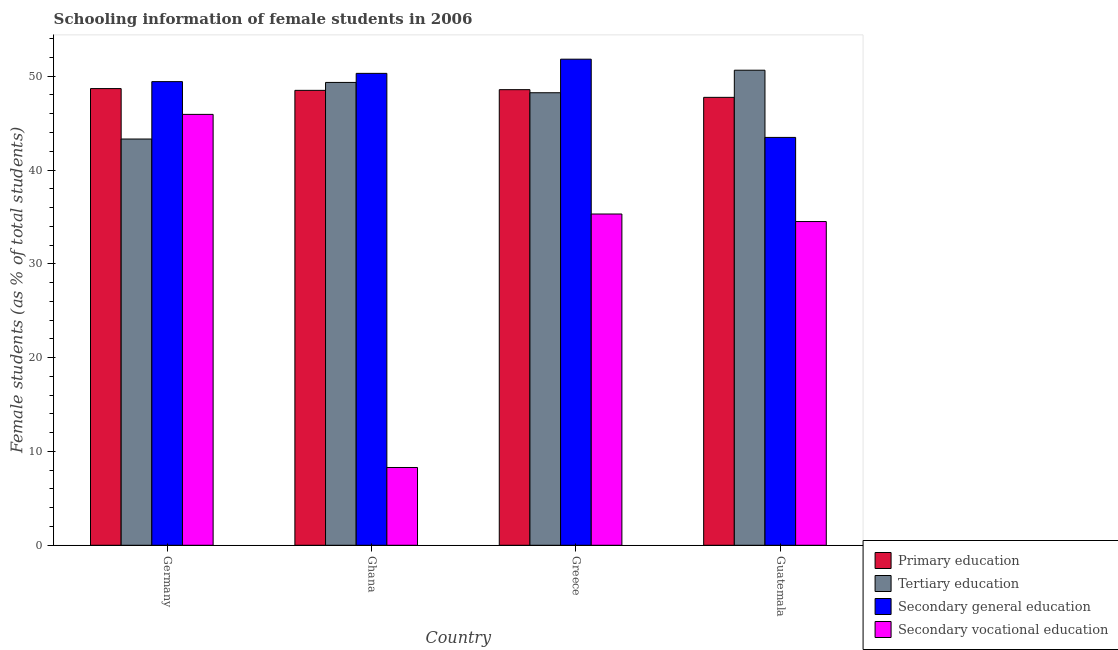How many groups of bars are there?
Your answer should be compact. 4. In how many cases, is the number of bars for a given country not equal to the number of legend labels?
Your response must be concise. 0. What is the percentage of female students in tertiary education in Guatemala?
Your answer should be very brief. 50.64. Across all countries, what is the maximum percentage of female students in secondary education?
Your response must be concise. 51.81. Across all countries, what is the minimum percentage of female students in tertiary education?
Make the answer very short. 43.3. In which country was the percentage of female students in tertiary education minimum?
Offer a terse response. Germany. What is the total percentage of female students in secondary education in the graph?
Your answer should be compact. 195.01. What is the difference between the percentage of female students in tertiary education in Ghana and that in Greece?
Provide a succinct answer. 1.1. What is the difference between the percentage of female students in secondary education in Greece and the percentage of female students in tertiary education in Guatemala?
Ensure brevity in your answer.  1.18. What is the average percentage of female students in primary education per country?
Provide a short and direct response. 48.37. What is the difference between the percentage of female students in tertiary education and percentage of female students in primary education in Ghana?
Your answer should be compact. 0.85. What is the ratio of the percentage of female students in secondary education in Germany to that in Greece?
Provide a short and direct response. 0.95. Is the percentage of female students in tertiary education in Ghana less than that in Greece?
Your response must be concise. No. Is the difference between the percentage of female students in secondary vocational education in Ghana and Guatemala greater than the difference between the percentage of female students in tertiary education in Ghana and Guatemala?
Provide a short and direct response. No. What is the difference between the highest and the second highest percentage of female students in secondary education?
Your answer should be compact. 1.51. What is the difference between the highest and the lowest percentage of female students in primary education?
Offer a terse response. 0.93. Is it the case that in every country, the sum of the percentage of female students in primary education and percentage of female students in secondary education is greater than the sum of percentage of female students in tertiary education and percentage of female students in secondary vocational education?
Your answer should be very brief. No. What does the 1st bar from the left in Guatemala represents?
Your response must be concise. Primary education. What does the 1st bar from the right in Greece represents?
Give a very brief answer. Secondary vocational education. How many bars are there?
Offer a terse response. 16. How many countries are there in the graph?
Make the answer very short. 4. Does the graph contain any zero values?
Keep it short and to the point. No. Where does the legend appear in the graph?
Give a very brief answer. Bottom right. How many legend labels are there?
Ensure brevity in your answer.  4. How are the legend labels stacked?
Make the answer very short. Vertical. What is the title of the graph?
Provide a short and direct response. Schooling information of female students in 2006. What is the label or title of the X-axis?
Provide a short and direct response. Country. What is the label or title of the Y-axis?
Provide a succinct answer. Female students (as % of total students). What is the Female students (as % of total students) of Primary education in Germany?
Give a very brief answer. 48.68. What is the Female students (as % of total students) in Tertiary education in Germany?
Ensure brevity in your answer.  43.3. What is the Female students (as % of total students) in Secondary general education in Germany?
Your answer should be very brief. 49.42. What is the Female students (as % of total students) of Secondary vocational education in Germany?
Offer a very short reply. 45.93. What is the Female students (as % of total students) in Primary education in Ghana?
Offer a very short reply. 48.49. What is the Female students (as % of total students) in Tertiary education in Ghana?
Keep it short and to the point. 49.34. What is the Female students (as % of total students) of Secondary general education in Ghana?
Offer a terse response. 50.3. What is the Female students (as % of total students) in Secondary vocational education in Ghana?
Keep it short and to the point. 8.29. What is the Female students (as % of total students) in Primary education in Greece?
Ensure brevity in your answer.  48.57. What is the Female students (as % of total students) of Tertiary education in Greece?
Your response must be concise. 48.24. What is the Female students (as % of total students) of Secondary general education in Greece?
Give a very brief answer. 51.81. What is the Female students (as % of total students) in Secondary vocational education in Greece?
Give a very brief answer. 35.31. What is the Female students (as % of total students) of Primary education in Guatemala?
Make the answer very short. 47.75. What is the Female students (as % of total students) of Tertiary education in Guatemala?
Keep it short and to the point. 50.64. What is the Female students (as % of total students) in Secondary general education in Guatemala?
Ensure brevity in your answer.  43.48. What is the Female students (as % of total students) in Secondary vocational education in Guatemala?
Provide a succinct answer. 34.51. Across all countries, what is the maximum Female students (as % of total students) of Primary education?
Provide a short and direct response. 48.68. Across all countries, what is the maximum Female students (as % of total students) in Tertiary education?
Make the answer very short. 50.64. Across all countries, what is the maximum Female students (as % of total students) of Secondary general education?
Keep it short and to the point. 51.81. Across all countries, what is the maximum Female students (as % of total students) in Secondary vocational education?
Your response must be concise. 45.93. Across all countries, what is the minimum Female students (as % of total students) of Primary education?
Provide a short and direct response. 47.75. Across all countries, what is the minimum Female students (as % of total students) of Tertiary education?
Provide a short and direct response. 43.3. Across all countries, what is the minimum Female students (as % of total students) of Secondary general education?
Your answer should be very brief. 43.48. Across all countries, what is the minimum Female students (as % of total students) of Secondary vocational education?
Ensure brevity in your answer.  8.29. What is the total Female students (as % of total students) of Primary education in the graph?
Provide a succinct answer. 193.48. What is the total Female students (as % of total students) of Tertiary education in the graph?
Your response must be concise. 191.52. What is the total Female students (as % of total students) in Secondary general education in the graph?
Keep it short and to the point. 195.01. What is the total Female students (as % of total students) of Secondary vocational education in the graph?
Give a very brief answer. 124.04. What is the difference between the Female students (as % of total students) of Primary education in Germany and that in Ghana?
Ensure brevity in your answer.  0.19. What is the difference between the Female students (as % of total students) of Tertiary education in Germany and that in Ghana?
Provide a short and direct response. -6.03. What is the difference between the Female students (as % of total students) in Secondary general education in Germany and that in Ghana?
Your answer should be very brief. -0.88. What is the difference between the Female students (as % of total students) of Secondary vocational education in Germany and that in Ghana?
Your response must be concise. 37.64. What is the difference between the Female students (as % of total students) in Primary education in Germany and that in Greece?
Your answer should be very brief. 0.11. What is the difference between the Female students (as % of total students) of Tertiary education in Germany and that in Greece?
Ensure brevity in your answer.  -4.93. What is the difference between the Female students (as % of total students) in Secondary general education in Germany and that in Greece?
Your response must be concise. -2.39. What is the difference between the Female students (as % of total students) of Secondary vocational education in Germany and that in Greece?
Offer a terse response. 10.62. What is the difference between the Female students (as % of total students) of Primary education in Germany and that in Guatemala?
Provide a succinct answer. 0.93. What is the difference between the Female students (as % of total students) of Tertiary education in Germany and that in Guatemala?
Your answer should be very brief. -7.33. What is the difference between the Female students (as % of total students) in Secondary general education in Germany and that in Guatemala?
Keep it short and to the point. 5.95. What is the difference between the Female students (as % of total students) of Secondary vocational education in Germany and that in Guatemala?
Give a very brief answer. 11.42. What is the difference between the Female students (as % of total students) of Primary education in Ghana and that in Greece?
Make the answer very short. -0.07. What is the difference between the Female students (as % of total students) of Tertiary education in Ghana and that in Greece?
Ensure brevity in your answer.  1.1. What is the difference between the Female students (as % of total students) in Secondary general education in Ghana and that in Greece?
Provide a short and direct response. -1.51. What is the difference between the Female students (as % of total students) of Secondary vocational education in Ghana and that in Greece?
Give a very brief answer. -27.02. What is the difference between the Female students (as % of total students) in Primary education in Ghana and that in Guatemala?
Your answer should be compact. 0.75. What is the difference between the Female students (as % of total students) in Tertiary education in Ghana and that in Guatemala?
Your response must be concise. -1.3. What is the difference between the Female students (as % of total students) of Secondary general education in Ghana and that in Guatemala?
Provide a short and direct response. 6.83. What is the difference between the Female students (as % of total students) in Secondary vocational education in Ghana and that in Guatemala?
Keep it short and to the point. -26.22. What is the difference between the Female students (as % of total students) of Primary education in Greece and that in Guatemala?
Make the answer very short. 0.82. What is the difference between the Female students (as % of total students) in Tertiary education in Greece and that in Guatemala?
Your answer should be compact. -2.4. What is the difference between the Female students (as % of total students) in Secondary general education in Greece and that in Guatemala?
Ensure brevity in your answer.  8.34. What is the difference between the Female students (as % of total students) of Secondary vocational education in Greece and that in Guatemala?
Your answer should be compact. 0.8. What is the difference between the Female students (as % of total students) in Primary education in Germany and the Female students (as % of total students) in Tertiary education in Ghana?
Keep it short and to the point. -0.66. What is the difference between the Female students (as % of total students) of Primary education in Germany and the Female students (as % of total students) of Secondary general education in Ghana?
Provide a succinct answer. -1.62. What is the difference between the Female students (as % of total students) of Primary education in Germany and the Female students (as % of total students) of Secondary vocational education in Ghana?
Your answer should be very brief. 40.39. What is the difference between the Female students (as % of total students) in Tertiary education in Germany and the Female students (as % of total students) in Secondary general education in Ghana?
Your answer should be compact. -7. What is the difference between the Female students (as % of total students) of Tertiary education in Germany and the Female students (as % of total students) of Secondary vocational education in Ghana?
Offer a terse response. 35.01. What is the difference between the Female students (as % of total students) of Secondary general education in Germany and the Female students (as % of total students) of Secondary vocational education in Ghana?
Make the answer very short. 41.13. What is the difference between the Female students (as % of total students) in Primary education in Germany and the Female students (as % of total students) in Tertiary education in Greece?
Make the answer very short. 0.44. What is the difference between the Female students (as % of total students) in Primary education in Germany and the Female students (as % of total students) in Secondary general education in Greece?
Your answer should be compact. -3.13. What is the difference between the Female students (as % of total students) in Primary education in Germany and the Female students (as % of total students) in Secondary vocational education in Greece?
Offer a terse response. 13.37. What is the difference between the Female students (as % of total students) of Tertiary education in Germany and the Female students (as % of total students) of Secondary general education in Greece?
Ensure brevity in your answer.  -8.51. What is the difference between the Female students (as % of total students) of Tertiary education in Germany and the Female students (as % of total students) of Secondary vocational education in Greece?
Offer a very short reply. 7.99. What is the difference between the Female students (as % of total students) in Secondary general education in Germany and the Female students (as % of total students) in Secondary vocational education in Greece?
Offer a terse response. 14.11. What is the difference between the Female students (as % of total students) in Primary education in Germany and the Female students (as % of total students) in Tertiary education in Guatemala?
Make the answer very short. -1.96. What is the difference between the Female students (as % of total students) in Primary education in Germany and the Female students (as % of total students) in Secondary general education in Guatemala?
Your response must be concise. 5.2. What is the difference between the Female students (as % of total students) of Primary education in Germany and the Female students (as % of total students) of Secondary vocational education in Guatemala?
Provide a succinct answer. 14.17. What is the difference between the Female students (as % of total students) of Tertiary education in Germany and the Female students (as % of total students) of Secondary general education in Guatemala?
Make the answer very short. -0.17. What is the difference between the Female students (as % of total students) of Tertiary education in Germany and the Female students (as % of total students) of Secondary vocational education in Guatemala?
Give a very brief answer. 8.8. What is the difference between the Female students (as % of total students) of Secondary general education in Germany and the Female students (as % of total students) of Secondary vocational education in Guatemala?
Your response must be concise. 14.91. What is the difference between the Female students (as % of total students) of Primary education in Ghana and the Female students (as % of total students) of Tertiary education in Greece?
Make the answer very short. 0.26. What is the difference between the Female students (as % of total students) in Primary education in Ghana and the Female students (as % of total students) in Secondary general education in Greece?
Make the answer very short. -3.32. What is the difference between the Female students (as % of total students) in Primary education in Ghana and the Female students (as % of total students) in Secondary vocational education in Greece?
Your response must be concise. 13.18. What is the difference between the Female students (as % of total students) of Tertiary education in Ghana and the Female students (as % of total students) of Secondary general education in Greece?
Offer a very short reply. -2.48. What is the difference between the Female students (as % of total students) of Tertiary education in Ghana and the Female students (as % of total students) of Secondary vocational education in Greece?
Give a very brief answer. 14.03. What is the difference between the Female students (as % of total students) of Secondary general education in Ghana and the Female students (as % of total students) of Secondary vocational education in Greece?
Keep it short and to the point. 14.99. What is the difference between the Female students (as % of total students) of Primary education in Ghana and the Female students (as % of total students) of Tertiary education in Guatemala?
Provide a succinct answer. -2.15. What is the difference between the Female students (as % of total students) of Primary education in Ghana and the Female students (as % of total students) of Secondary general education in Guatemala?
Your response must be concise. 5.02. What is the difference between the Female students (as % of total students) of Primary education in Ghana and the Female students (as % of total students) of Secondary vocational education in Guatemala?
Ensure brevity in your answer.  13.98. What is the difference between the Female students (as % of total students) in Tertiary education in Ghana and the Female students (as % of total students) in Secondary general education in Guatemala?
Offer a terse response. 5.86. What is the difference between the Female students (as % of total students) in Tertiary education in Ghana and the Female students (as % of total students) in Secondary vocational education in Guatemala?
Provide a succinct answer. 14.83. What is the difference between the Female students (as % of total students) in Secondary general education in Ghana and the Female students (as % of total students) in Secondary vocational education in Guatemala?
Ensure brevity in your answer.  15.79. What is the difference between the Female students (as % of total students) of Primary education in Greece and the Female students (as % of total students) of Tertiary education in Guatemala?
Make the answer very short. -2.07. What is the difference between the Female students (as % of total students) of Primary education in Greece and the Female students (as % of total students) of Secondary general education in Guatemala?
Provide a succinct answer. 5.09. What is the difference between the Female students (as % of total students) in Primary education in Greece and the Female students (as % of total students) in Secondary vocational education in Guatemala?
Offer a terse response. 14.06. What is the difference between the Female students (as % of total students) in Tertiary education in Greece and the Female students (as % of total students) in Secondary general education in Guatemala?
Give a very brief answer. 4.76. What is the difference between the Female students (as % of total students) of Tertiary education in Greece and the Female students (as % of total students) of Secondary vocational education in Guatemala?
Ensure brevity in your answer.  13.73. What is the difference between the Female students (as % of total students) of Secondary general education in Greece and the Female students (as % of total students) of Secondary vocational education in Guatemala?
Provide a short and direct response. 17.31. What is the average Female students (as % of total students) in Primary education per country?
Provide a succinct answer. 48.37. What is the average Female students (as % of total students) of Tertiary education per country?
Make the answer very short. 47.88. What is the average Female students (as % of total students) of Secondary general education per country?
Give a very brief answer. 48.75. What is the average Female students (as % of total students) of Secondary vocational education per country?
Make the answer very short. 31.01. What is the difference between the Female students (as % of total students) of Primary education and Female students (as % of total students) of Tertiary education in Germany?
Keep it short and to the point. 5.38. What is the difference between the Female students (as % of total students) of Primary education and Female students (as % of total students) of Secondary general education in Germany?
Keep it short and to the point. -0.74. What is the difference between the Female students (as % of total students) of Primary education and Female students (as % of total students) of Secondary vocational education in Germany?
Give a very brief answer. 2.75. What is the difference between the Female students (as % of total students) in Tertiary education and Female students (as % of total students) in Secondary general education in Germany?
Give a very brief answer. -6.12. What is the difference between the Female students (as % of total students) in Tertiary education and Female students (as % of total students) in Secondary vocational education in Germany?
Give a very brief answer. -2.63. What is the difference between the Female students (as % of total students) in Secondary general education and Female students (as % of total students) in Secondary vocational education in Germany?
Provide a short and direct response. 3.49. What is the difference between the Female students (as % of total students) in Primary education and Female students (as % of total students) in Tertiary education in Ghana?
Give a very brief answer. -0.85. What is the difference between the Female students (as % of total students) in Primary education and Female students (as % of total students) in Secondary general education in Ghana?
Offer a terse response. -1.81. What is the difference between the Female students (as % of total students) of Primary education and Female students (as % of total students) of Secondary vocational education in Ghana?
Make the answer very short. 40.2. What is the difference between the Female students (as % of total students) of Tertiary education and Female students (as % of total students) of Secondary general education in Ghana?
Provide a short and direct response. -0.97. What is the difference between the Female students (as % of total students) of Tertiary education and Female students (as % of total students) of Secondary vocational education in Ghana?
Your answer should be very brief. 41.05. What is the difference between the Female students (as % of total students) in Secondary general education and Female students (as % of total students) in Secondary vocational education in Ghana?
Your answer should be compact. 42.01. What is the difference between the Female students (as % of total students) of Primary education and Female students (as % of total students) of Tertiary education in Greece?
Provide a succinct answer. 0.33. What is the difference between the Female students (as % of total students) of Primary education and Female students (as % of total students) of Secondary general education in Greece?
Your answer should be compact. -3.25. What is the difference between the Female students (as % of total students) of Primary education and Female students (as % of total students) of Secondary vocational education in Greece?
Provide a succinct answer. 13.25. What is the difference between the Female students (as % of total students) in Tertiary education and Female students (as % of total students) in Secondary general education in Greece?
Make the answer very short. -3.58. What is the difference between the Female students (as % of total students) of Tertiary education and Female students (as % of total students) of Secondary vocational education in Greece?
Provide a succinct answer. 12.93. What is the difference between the Female students (as % of total students) of Secondary general education and Female students (as % of total students) of Secondary vocational education in Greece?
Your answer should be compact. 16.5. What is the difference between the Female students (as % of total students) in Primary education and Female students (as % of total students) in Tertiary education in Guatemala?
Provide a succinct answer. -2.89. What is the difference between the Female students (as % of total students) of Primary education and Female students (as % of total students) of Secondary general education in Guatemala?
Make the answer very short. 4.27. What is the difference between the Female students (as % of total students) of Primary education and Female students (as % of total students) of Secondary vocational education in Guatemala?
Your answer should be compact. 13.24. What is the difference between the Female students (as % of total students) in Tertiary education and Female students (as % of total students) in Secondary general education in Guatemala?
Give a very brief answer. 7.16. What is the difference between the Female students (as % of total students) in Tertiary education and Female students (as % of total students) in Secondary vocational education in Guatemala?
Your response must be concise. 16.13. What is the difference between the Female students (as % of total students) of Secondary general education and Female students (as % of total students) of Secondary vocational education in Guatemala?
Make the answer very short. 8.97. What is the ratio of the Female students (as % of total students) in Tertiary education in Germany to that in Ghana?
Ensure brevity in your answer.  0.88. What is the ratio of the Female students (as % of total students) in Secondary general education in Germany to that in Ghana?
Provide a succinct answer. 0.98. What is the ratio of the Female students (as % of total students) of Secondary vocational education in Germany to that in Ghana?
Offer a terse response. 5.54. What is the ratio of the Female students (as % of total students) of Primary education in Germany to that in Greece?
Keep it short and to the point. 1. What is the ratio of the Female students (as % of total students) in Tertiary education in Germany to that in Greece?
Your answer should be compact. 0.9. What is the ratio of the Female students (as % of total students) of Secondary general education in Germany to that in Greece?
Keep it short and to the point. 0.95. What is the ratio of the Female students (as % of total students) of Secondary vocational education in Germany to that in Greece?
Make the answer very short. 1.3. What is the ratio of the Female students (as % of total students) in Primary education in Germany to that in Guatemala?
Your response must be concise. 1.02. What is the ratio of the Female students (as % of total students) of Tertiary education in Germany to that in Guatemala?
Ensure brevity in your answer.  0.86. What is the ratio of the Female students (as % of total students) in Secondary general education in Germany to that in Guatemala?
Make the answer very short. 1.14. What is the ratio of the Female students (as % of total students) of Secondary vocational education in Germany to that in Guatemala?
Your answer should be compact. 1.33. What is the ratio of the Female students (as % of total students) of Primary education in Ghana to that in Greece?
Your answer should be very brief. 1. What is the ratio of the Female students (as % of total students) in Tertiary education in Ghana to that in Greece?
Ensure brevity in your answer.  1.02. What is the ratio of the Female students (as % of total students) of Secondary general education in Ghana to that in Greece?
Make the answer very short. 0.97. What is the ratio of the Female students (as % of total students) of Secondary vocational education in Ghana to that in Greece?
Your response must be concise. 0.23. What is the ratio of the Female students (as % of total students) in Primary education in Ghana to that in Guatemala?
Provide a short and direct response. 1.02. What is the ratio of the Female students (as % of total students) in Tertiary education in Ghana to that in Guatemala?
Offer a very short reply. 0.97. What is the ratio of the Female students (as % of total students) in Secondary general education in Ghana to that in Guatemala?
Your answer should be compact. 1.16. What is the ratio of the Female students (as % of total students) in Secondary vocational education in Ghana to that in Guatemala?
Your answer should be very brief. 0.24. What is the ratio of the Female students (as % of total students) of Primary education in Greece to that in Guatemala?
Make the answer very short. 1.02. What is the ratio of the Female students (as % of total students) of Tertiary education in Greece to that in Guatemala?
Your answer should be very brief. 0.95. What is the ratio of the Female students (as % of total students) of Secondary general education in Greece to that in Guatemala?
Give a very brief answer. 1.19. What is the ratio of the Female students (as % of total students) in Secondary vocational education in Greece to that in Guatemala?
Provide a short and direct response. 1.02. What is the difference between the highest and the second highest Female students (as % of total students) of Primary education?
Ensure brevity in your answer.  0.11. What is the difference between the highest and the second highest Female students (as % of total students) of Tertiary education?
Give a very brief answer. 1.3. What is the difference between the highest and the second highest Female students (as % of total students) of Secondary general education?
Offer a very short reply. 1.51. What is the difference between the highest and the second highest Female students (as % of total students) in Secondary vocational education?
Your response must be concise. 10.62. What is the difference between the highest and the lowest Female students (as % of total students) of Primary education?
Your answer should be compact. 0.93. What is the difference between the highest and the lowest Female students (as % of total students) of Tertiary education?
Give a very brief answer. 7.33. What is the difference between the highest and the lowest Female students (as % of total students) of Secondary general education?
Make the answer very short. 8.34. What is the difference between the highest and the lowest Female students (as % of total students) of Secondary vocational education?
Ensure brevity in your answer.  37.64. 